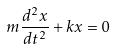Convert formula to latex. <formula><loc_0><loc_0><loc_500><loc_500>m \frac { d ^ { 2 } x } { d t ^ { 2 } } + k x = 0</formula> 